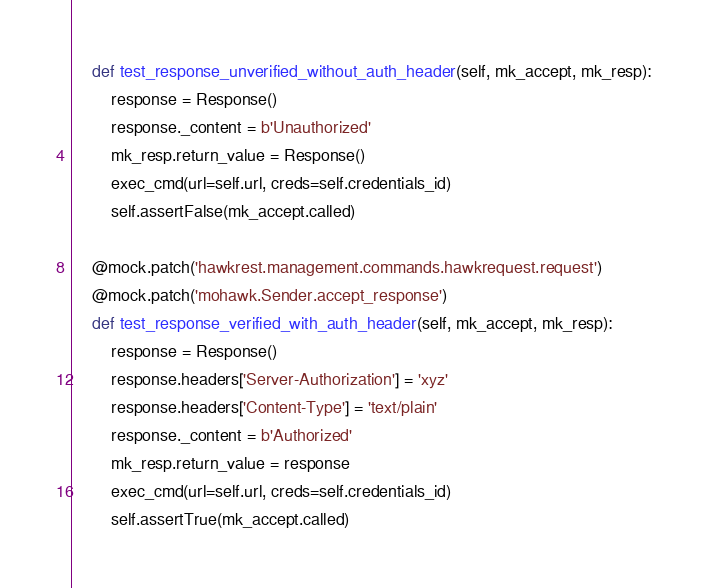<code> <loc_0><loc_0><loc_500><loc_500><_Python_>    def test_response_unverified_without_auth_header(self, mk_accept, mk_resp):
        response = Response()
        response._content = b'Unauthorized'
        mk_resp.return_value = Response()
        exec_cmd(url=self.url, creds=self.credentials_id)
        self.assertFalse(mk_accept.called)

    @mock.patch('hawkrest.management.commands.hawkrequest.request')
    @mock.patch('mohawk.Sender.accept_response')
    def test_response_verified_with_auth_header(self, mk_accept, mk_resp):
        response = Response()
        response.headers['Server-Authorization'] = 'xyz'
        response.headers['Content-Type'] = 'text/plain'
        response._content = b'Authorized'
        mk_resp.return_value = response
        exec_cmd(url=self.url, creds=self.credentials_id)
        self.assertTrue(mk_accept.called)
</code> 